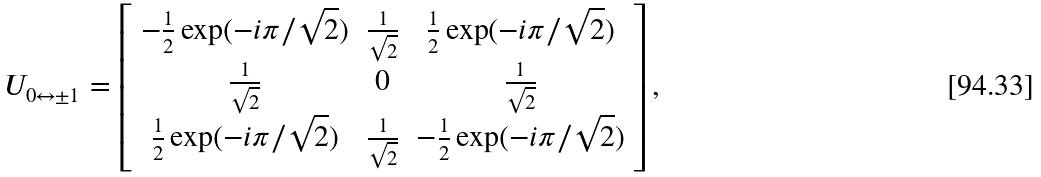<formula> <loc_0><loc_0><loc_500><loc_500>U _ { 0 \leftrightarrow \pm 1 } = \left [ \begin{array} { c c c } - \frac { 1 } { 2 } \exp ( - i \pi / \sqrt { 2 } ) & \frac { 1 } { \sqrt { 2 } } & \frac { 1 } { 2 } \exp ( - i \pi / \sqrt { 2 } ) \\ \frac { 1 } { \sqrt { 2 } } & 0 & \frac { 1 } { \sqrt { 2 } } \\ \frac { 1 } { 2 } \exp ( - i \pi / \sqrt { 2 } ) & \frac { 1 } { \sqrt { 2 } } & - \frac { 1 } { 2 } \exp ( - i \pi / \sqrt { 2 } ) \end{array} \right ] ,</formula> 